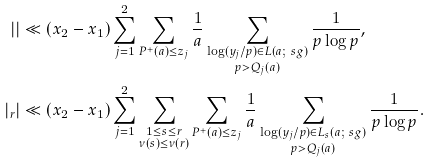<formula> <loc_0><loc_0><loc_500><loc_500>| \AA | & \ll ( x _ { 2 } - x _ { 1 } ) \sum _ { j = 1 } ^ { 2 } \sum _ { P ^ { + } ( a ) \leq z _ { j } } \frac { 1 } { a } \sum _ { \substack { \log ( y _ { j } / p ) \in \L L ( a ; \ s g ) \\ p > Q _ { j } ( a ) } } \frac { 1 } { p \log p } , \\ | \AA _ { r } | & \ll ( x _ { 2 } - x _ { 1 } ) \sum _ { j = 1 } ^ { 2 } \sum _ { \substack { 1 \leq s \leq r \\ \nu ( s ) \leq \nu ( r ) } } \sum _ { P ^ { + } ( a ) \leq z _ { j } } \frac { 1 } { a } \sum _ { \substack { \log ( y _ { j } / p ) \in \L L _ { s } ( a ; \ s g ) \\ p > Q _ { j } ( a ) } } \frac { 1 } { p \log p } .</formula> 